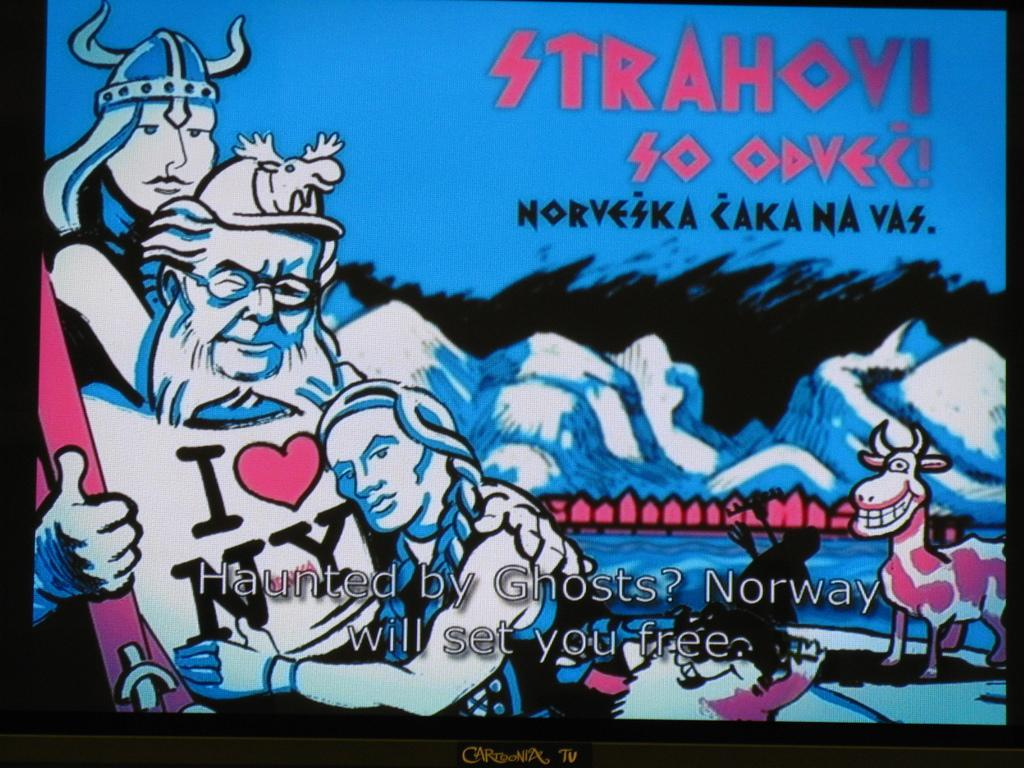<image>
Render a clear and concise summary of the photo. A sign showing illustrated Vikings, one wearing an I love NY shirt, promotes Norway. 